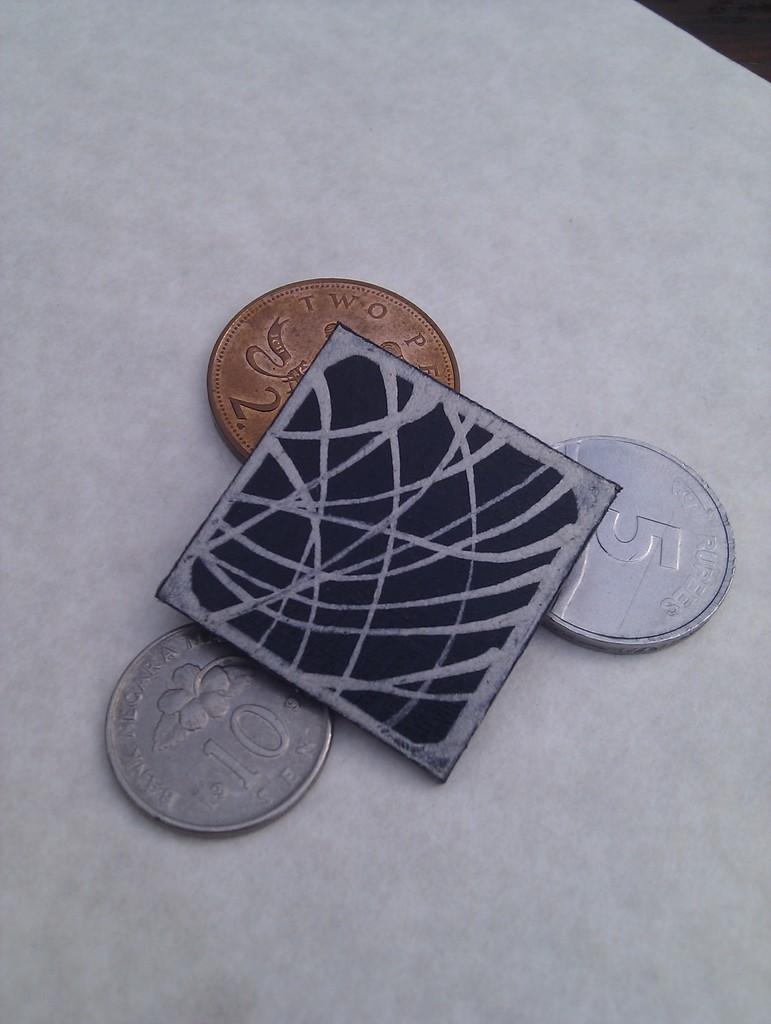Provide a one-sentence caption for the provided image. a small square on top of a gold coin and two silver coins with one of them with the number 5 on it. 